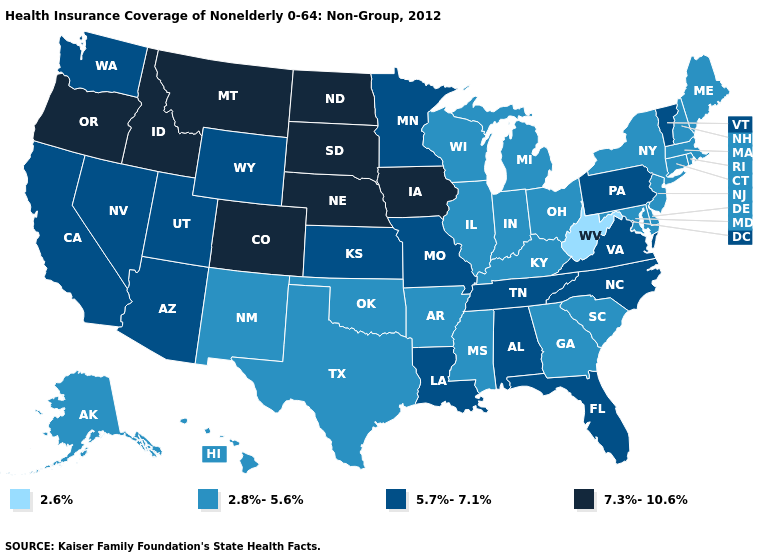Name the states that have a value in the range 5.7%-7.1%?
Answer briefly. Alabama, Arizona, California, Florida, Kansas, Louisiana, Minnesota, Missouri, Nevada, North Carolina, Pennsylvania, Tennessee, Utah, Vermont, Virginia, Washington, Wyoming. Which states have the lowest value in the South?
Answer briefly. West Virginia. Which states have the highest value in the USA?
Keep it brief. Colorado, Idaho, Iowa, Montana, Nebraska, North Dakota, Oregon, South Dakota. Does Louisiana have the same value as Alaska?
Keep it brief. No. Is the legend a continuous bar?
Give a very brief answer. No. What is the value of Maine?
Be succinct. 2.8%-5.6%. Does Colorado have the same value as Iowa?
Give a very brief answer. Yes. What is the value of Virginia?
Concise answer only. 5.7%-7.1%. Which states have the lowest value in the USA?
Concise answer only. West Virginia. What is the highest value in states that border Tennessee?
Be succinct. 5.7%-7.1%. Name the states that have a value in the range 2.6%?
Keep it brief. West Virginia. Name the states that have a value in the range 2.6%?
Answer briefly. West Virginia. What is the highest value in the USA?
Keep it brief. 7.3%-10.6%. Among the states that border Utah , which have the highest value?
Keep it brief. Colorado, Idaho. 